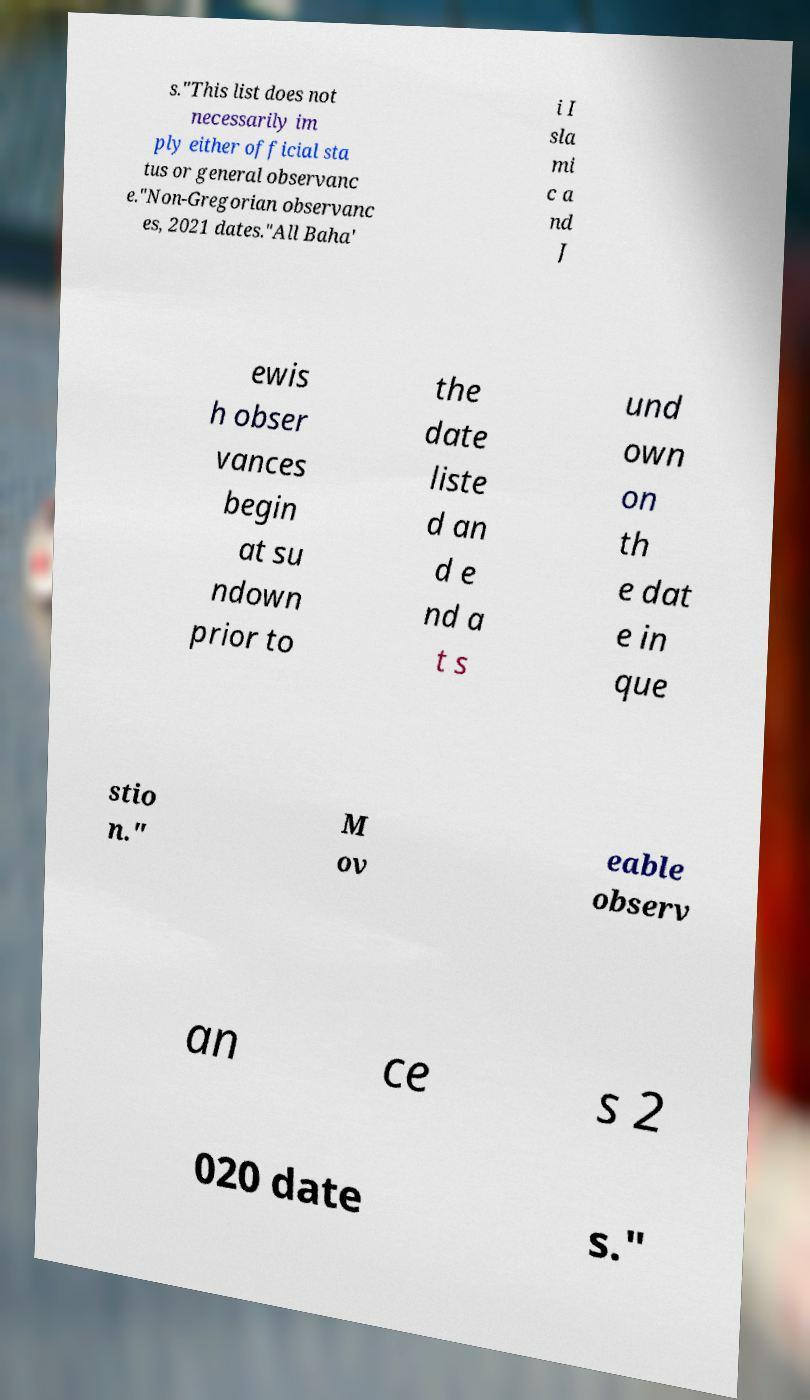What messages or text are displayed in this image? I need them in a readable, typed format. s."This list does not necessarily im ply either official sta tus or general observanc e."Non-Gregorian observanc es, 2021 dates."All Baha' i I sla mi c a nd J ewis h obser vances begin at su ndown prior to the date liste d an d e nd a t s und own on th e dat e in que stio n." M ov eable observ an ce s 2 020 date s." 